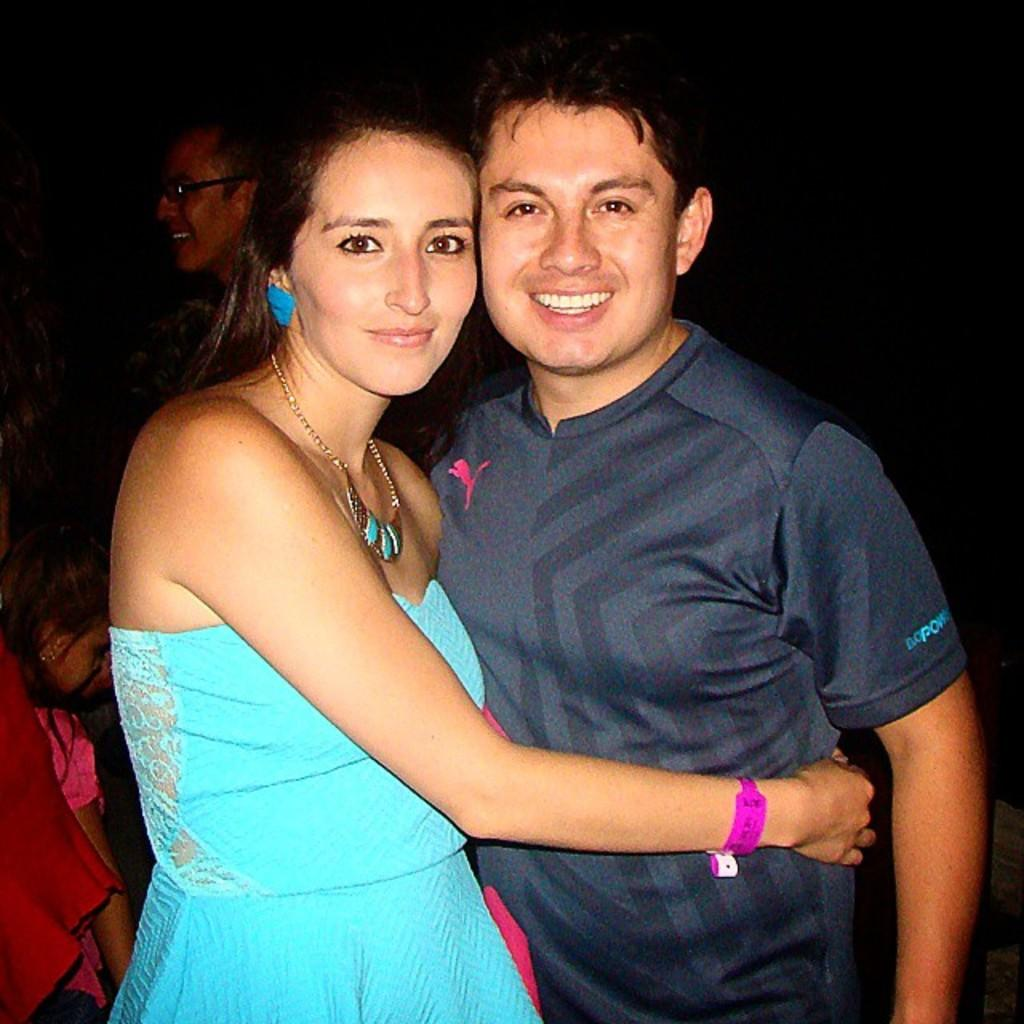How many people are visible in the image? There are at least three people visible in the image. Can you describe the positioning of the people in the image? There are two persons standing in the middle of the image, and there are additional persons on the left side of the image. What type of brush is the father using to care for the plants in the image? There is no father or plants present in the image, and therefore no such activity can be observed. 